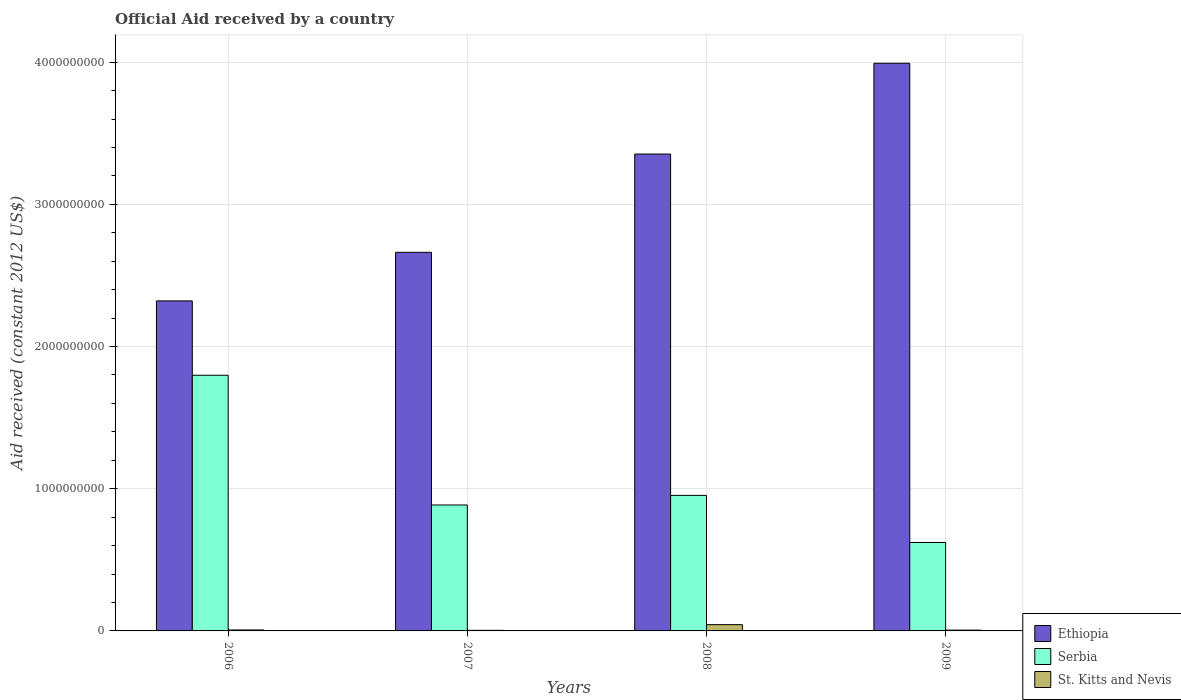How many different coloured bars are there?
Your response must be concise. 3. How many bars are there on the 1st tick from the left?
Your answer should be very brief. 3. How many bars are there on the 4th tick from the right?
Keep it short and to the point. 3. What is the label of the 4th group of bars from the left?
Give a very brief answer. 2009. In how many cases, is the number of bars for a given year not equal to the number of legend labels?
Your answer should be very brief. 0. What is the net official aid received in St. Kitts and Nevis in 2008?
Offer a very short reply. 4.41e+07. Across all years, what is the maximum net official aid received in Ethiopia?
Make the answer very short. 3.99e+09. Across all years, what is the minimum net official aid received in Serbia?
Give a very brief answer. 6.22e+08. In which year was the net official aid received in Serbia minimum?
Make the answer very short. 2009. What is the total net official aid received in St. Kitts and Nevis in the graph?
Your answer should be very brief. 6.07e+07. What is the difference between the net official aid received in Ethiopia in 2007 and that in 2008?
Give a very brief answer. -6.91e+08. What is the difference between the net official aid received in Ethiopia in 2008 and the net official aid received in St. Kitts and Nevis in 2007?
Offer a terse response. 3.35e+09. What is the average net official aid received in Ethiopia per year?
Give a very brief answer. 3.08e+09. In the year 2007, what is the difference between the net official aid received in St. Kitts and Nevis and net official aid received in Serbia?
Provide a succinct answer. -8.82e+08. In how many years, is the net official aid received in St. Kitts and Nevis greater than 800000000 US$?
Offer a very short reply. 0. What is the ratio of the net official aid received in St. Kitts and Nevis in 2007 to that in 2009?
Keep it short and to the point. 0.76. Is the net official aid received in Ethiopia in 2006 less than that in 2009?
Keep it short and to the point. Yes. What is the difference between the highest and the second highest net official aid received in Ethiopia?
Provide a succinct answer. 6.38e+08. What is the difference between the highest and the lowest net official aid received in St. Kitts and Nevis?
Offer a very short reply. 3.99e+07. What does the 2nd bar from the left in 2008 represents?
Offer a terse response. Serbia. What does the 1st bar from the right in 2007 represents?
Your answer should be very brief. St. Kitts and Nevis. Is it the case that in every year, the sum of the net official aid received in Serbia and net official aid received in Ethiopia is greater than the net official aid received in St. Kitts and Nevis?
Your answer should be very brief. Yes. How many bars are there?
Give a very brief answer. 12. Are all the bars in the graph horizontal?
Offer a terse response. No. What is the difference between two consecutive major ticks on the Y-axis?
Keep it short and to the point. 1.00e+09. Does the graph contain grids?
Make the answer very short. Yes. Where does the legend appear in the graph?
Make the answer very short. Bottom right. What is the title of the graph?
Your response must be concise. Official Aid received by a country. What is the label or title of the Y-axis?
Offer a very short reply. Aid received (constant 2012 US$). What is the Aid received (constant 2012 US$) in Ethiopia in 2006?
Ensure brevity in your answer.  2.32e+09. What is the Aid received (constant 2012 US$) of Serbia in 2006?
Provide a short and direct response. 1.80e+09. What is the Aid received (constant 2012 US$) of St. Kitts and Nevis in 2006?
Ensure brevity in your answer.  6.74e+06. What is the Aid received (constant 2012 US$) of Ethiopia in 2007?
Make the answer very short. 2.66e+09. What is the Aid received (constant 2012 US$) of Serbia in 2007?
Ensure brevity in your answer.  8.86e+08. What is the Aid received (constant 2012 US$) in St. Kitts and Nevis in 2007?
Give a very brief answer. 4.22e+06. What is the Aid received (constant 2012 US$) in Ethiopia in 2008?
Provide a succinct answer. 3.35e+09. What is the Aid received (constant 2012 US$) of Serbia in 2008?
Provide a succinct answer. 9.53e+08. What is the Aid received (constant 2012 US$) in St. Kitts and Nevis in 2008?
Your answer should be very brief. 4.41e+07. What is the Aid received (constant 2012 US$) of Ethiopia in 2009?
Keep it short and to the point. 3.99e+09. What is the Aid received (constant 2012 US$) of Serbia in 2009?
Ensure brevity in your answer.  6.22e+08. What is the Aid received (constant 2012 US$) in St. Kitts and Nevis in 2009?
Your answer should be very brief. 5.58e+06. Across all years, what is the maximum Aid received (constant 2012 US$) of Ethiopia?
Provide a short and direct response. 3.99e+09. Across all years, what is the maximum Aid received (constant 2012 US$) in Serbia?
Ensure brevity in your answer.  1.80e+09. Across all years, what is the maximum Aid received (constant 2012 US$) in St. Kitts and Nevis?
Your response must be concise. 4.41e+07. Across all years, what is the minimum Aid received (constant 2012 US$) of Ethiopia?
Offer a very short reply. 2.32e+09. Across all years, what is the minimum Aid received (constant 2012 US$) in Serbia?
Your answer should be very brief. 6.22e+08. Across all years, what is the minimum Aid received (constant 2012 US$) of St. Kitts and Nevis?
Your answer should be compact. 4.22e+06. What is the total Aid received (constant 2012 US$) in Ethiopia in the graph?
Offer a very short reply. 1.23e+1. What is the total Aid received (constant 2012 US$) of Serbia in the graph?
Offer a terse response. 4.26e+09. What is the total Aid received (constant 2012 US$) in St. Kitts and Nevis in the graph?
Offer a terse response. 6.07e+07. What is the difference between the Aid received (constant 2012 US$) of Ethiopia in 2006 and that in 2007?
Your response must be concise. -3.42e+08. What is the difference between the Aid received (constant 2012 US$) of Serbia in 2006 and that in 2007?
Your answer should be very brief. 9.12e+08. What is the difference between the Aid received (constant 2012 US$) in St. Kitts and Nevis in 2006 and that in 2007?
Your answer should be very brief. 2.52e+06. What is the difference between the Aid received (constant 2012 US$) of Ethiopia in 2006 and that in 2008?
Offer a terse response. -1.03e+09. What is the difference between the Aid received (constant 2012 US$) of Serbia in 2006 and that in 2008?
Provide a succinct answer. 8.45e+08. What is the difference between the Aid received (constant 2012 US$) of St. Kitts and Nevis in 2006 and that in 2008?
Provide a short and direct response. -3.74e+07. What is the difference between the Aid received (constant 2012 US$) of Ethiopia in 2006 and that in 2009?
Keep it short and to the point. -1.67e+09. What is the difference between the Aid received (constant 2012 US$) in Serbia in 2006 and that in 2009?
Provide a short and direct response. 1.18e+09. What is the difference between the Aid received (constant 2012 US$) in St. Kitts and Nevis in 2006 and that in 2009?
Your answer should be compact. 1.16e+06. What is the difference between the Aid received (constant 2012 US$) of Ethiopia in 2007 and that in 2008?
Your answer should be compact. -6.91e+08. What is the difference between the Aid received (constant 2012 US$) of Serbia in 2007 and that in 2008?
Ensure brevity in your answer.  -6.75e+07. What is the difference between the Aid received (constant 2012 US$) in St. Kitts and Nevis in 2007 and that in 2008?
Provide a short and direct response. -3.99e+07. What is the difference between the Aid received (constant 2012 US$) in Ethiopia in 2007 and that in 2009?
Provide a succinct answer. -1.33e+09. What is the difference between the Aid received (constant 2012 US$) of Serbia in 2007 and that in 2009?
Provide a succinct answer. 2.64e+08. What is the difference between the Aid received (constant 2012 US$) in St. Kitts and Nevis in 2007 and that in 2009?
Your answer should be very brief. -1.36e+06. What is the difference between the Aid received (constant 2012 US$) of Ethiopia in 2008 and that in 2009?
Give a very brief answer. -6.38e+08. What is the difference between the Aid received (constant 2012 US$) of Serbia in 2008 and that in 2009?
Provide a short and direct response. 3.31e+08. What is the difference between the Aid received (constant 2012 US$) of St. Kitts and Nevis in 2008 and that in 2009?
Ensure brevity in your answer.  3.86e+07. What is the difference between the Aid received (constant 2012 US$) of Ethiopia in 2006 and the Aid received (constant 2012 US$) of Serbia in 2007?
Offer a terse response. 1.44e+09. What is the difference between the Aid received (constant 2012 US$) of Ethiopia in 2006 and the Aid received (constant 2012 US$) of St. Kitts and Nevis in 2007?
Offer a terse response. 2.32e+09. What is the difference between the Aid received (constant 2012 US$) of Serbia in 2006 and the Aid received (constant 2012 US$) of St. Kitts and Nevis in 2007?
Your response must be concise. 1.79e+09. What is the difference between the Aid received (constant 2012 US$) of Ethiopia in 2006 and the Aid received (constant 2012 US$) of Serbia in 2008?
Offer a terse response. 1.37e+09. What is the difference between the Aid received (constant 2012 US$) of Ethiopia in 2006 and the Aid received (constant 2012 US$) of St. Kitts and Nevis in 2008?
Your answer should be compact. 2.28e+09. What is the difference between the Aid received (constant 2012 US$) in Serbia in 2006 and the Aid received (constant 2012 US$) in St. Kitts and Nevis in 2008?
Your answer should be compact. 1.75e+09. What is the difference between the Aid received (constant 2012 US$) in Ethiopia in 2006 and the Aid received (constant 2012 US$) in Serbia in 2009?
Ensure brevity in your answer.  1.70e+09. What is the difference between the Aid received (constant 2012 US$) of Ethiopia in 2006 and the Aid received (constant 2012 US$) of St. Kitts and Nevis in 2009?
Provide a short and direct response. 2.32e+09. What is the difference between the Aid received (constant 2012 US$) of Serbia in 2006 and the Aid received (constant 2012 US$) of St. Kitts and Nevis in 2009?
Provide a succinct answer. 1.79e+09. What is the difference between the Aid received (constant 2012 US$) of Ethiopia in 2007 and the Aid received (constant 2012 US$) of Serbia in 2008?
Your answer should be very brief. 1.71e+09. What is the difference between the Aid received (constant 2012 US$) in Ethiopia in 2007 and the Aid received (constant 2012 US$) in St. Kitts and Nevis in 2008?
Ensure brevity in your answer.  2.62e+09. What is the difference between the Aid received (constant 2012 US$) of Serbia in 2007 and the Aid received (constant 2012 US$) of St. Kitts and Nevis in 2008?
Give a very brief answer. 8.42e+08. What is the difference between the Aid received (constant 2012 US$) in Ethiopia in 2007 and the Aid received (constant 2012 US$) in Serbia in 2009?
Offer a terse response. 2.04e+09. What is the difference between the Aid received (constant 2012 US$) in Ethiopia in 2007 and the Aid received (constant 2012 US$) in St. Kitts and Nevis in 2009?
Your answer should be very brief. 2.66e+09. What is the difference between the Aid received (constant 2012 US$) in Serbia in 2007 and the Aid received (constant 2012 US$) in St. Kitts and Nevis in 2009?
Offer a terse response. 8.80e+08. What is the difference between the Aid received (constant 2012 US$) of Ethiopia in 2008 and the Aid received (constant 2012 US$) of Serbia in 2009?
Make the answer very short. 2.73e+09. What is the difference between the Aid received (constant 2012 US$) in Ethiopia in 2008 and the Aid received (constant 2012 US$) in St. Kitts and Nevis in 2009?
Provide a short and direct response. 3.35e+09. What is the difference between the Aid received (constant 2012 US$) in Serbia in 2008 and the Aid received (constant 2012 US$) in St. Kitts and Nevis in 2009?
Offer a very short reply. 9.48e+08. What is the average Aid received (constant 2012 US$) of Ethiopia per year?
Make the answer very short. 3.08e+09. What is the average Aid received (constant 2012 US$) in Serbia per year?
Ensure brevity in your answer.  1.06e+09. What is the average Aid received (constant 2012 US$) in St. Kitts and Nevis per year?
Provide a short and direct response. 1.52e+07. In the year 2006, what is the difference between the Aid received (constant 2012 US$) in Ethiopia and Aid received (constant 2012 US$) in Serbia?
Your answer should be very brief. 5.23e+08. In the year 2006, what is the difference between the Aid received (constant 2012 US$) of Ethiopia and Aid received (constant 2012 US$) of St. Kitts and Nevis?
Give a very brief answer. 2.31e+09. In the year 2006, what is the difference between the Aid received (constant 2012 US$) in Serbia and Aid received (constant 2012 US$) in St. Kitts and Nevis?
Ensure brevity in your answer.  1.79e+09. In the year 2007, what is the difference between the Aid received (constant 2012 US$) in Ethiopia and Aid received (constant 2012 US$) in Serbia?
Offer a very short reply. 1.78e+09. In the year 2007, what is the difference between the Aid received (constant 2012 US$) of Ethiopia and Aid received (constant 2012 US$) of St. Kitts and Nevis?
Provide a succinct answer. 2.66e+09. In the year 2007, what is the difference between the Aid received (constant 2012 US$) in Serbia and Aid received (constant 2012 US$) in St. Kitts and Nevis?
Keep it short and to the point. 8.82e+08. In the year 2008, what is the difference between the Aid received (constant 2012 US$) in Ethiopia and Aid received (constant 2012 US$) in Serbia?
Your answer should be very brief. 2.40e+09. In the year 2008, what is the difference between the Aid received (constant 2012 US$) of Ethiopia and Aid received (constant 2012 US$) of St. Kitts and Nevis?
Your answer should be compact. 3.31e+09. In the year 2008, what is the difference between the Aid received (constant 2012 US$) in Serbia and Aid received (constant 2012 US$) in St. Kitts and Nevis?
Your response must be concise. 9.09e+08. In the year 2009, what is the difference between the Aid received (constant 2012 US$) of Ethiopia and Aid received (constant 2012 US$) of Serbia?
Offer a terse response. 3.37e+09. In the year 2009, what is the difference between the Aid received (constant 2012 US$) in Ethiopia and Aid received (constant 2012 US$) in St. Kitts and Nevis?
Make the answer very short. 3.99e+09. In the year 2009, what is the difference between the Aid received (constant 2012 US$) in Serbia and Aid received (constant 2012 US$) in St. Kitts and Nevis?
Keep it short and to the point. 6.16e+08. What is the ratio of the Aid received (constant 2012 US$) in Ethiopia in 2006 to that in 2007?
Offer a very short reply. 0.87. What is the ratio of the Aid received (constant 2012 US$) in Serbia in 2006 to that in 2007?
Ensure brevity in your answer.  2.03. What is the ratio of the Aid received (constant 2012 US$) of St. Kitts and Nevis in 2006 to that in 2007?
Offer a very short reply. 1.6. What is the ratio of the Aid received (constant 2012 US$) in Ethiopia in 2006 to that in 2008?
Provide a succinct answer. 0.69. What is the ratio of the Aid received (constant 2012 US$) in Serbia in 2006 to that in 2008?
Keep it short and to the point. 1.89. What is the ratio of the Aid received (constant 2012 US$) in St. Kitts and Nevis in 2006 to that in 2008?
Offer a very short reply. 0.15. What is the ratio of the Aid received (constant 2012 US$) in Ethiopia in 2006 to that in 2009?
Your answer should be compact. 0.58. What is the ratio of the Aid received (constant 2012 US$) in Serbia in 2006 to that in 2009?
Provide a short and direct response. 2.89. What is the ratio of the Aid received (constant 2012 US$) of St. Kitts and Nevis in 2006 to that in 2009?
Your answer should be compact. 1.21. What is the ratio of the Aid received (constant 2012 US$) of Ethiopia in 2007 to that in 2008?
Keep it short and to the point. 0.79. What is the ratio of the Aid received (constant 2012 US$) of Serbia in 2007 to that in 2008?
Your response must be concise. 0.93. What is the ratio of the Aid received (constant 2012 US$) in St. Kitts and Nevis in 2007 to that in 2008?
Provide a short and direct response. 0.1. What is the ratio of the Aid received (constant 2012 US$) in Ethiopia in 2007 to that in 2009?
Your answer should be very brief. 0.67. What is the ratio of the Aid received (constant 2012 US$) of Serbia in 2007 to that in 2009?
Your answer should be compact. 1.42. What is the ratio of the Aid received (constant 2012 US$) in St. Kitts and Nevis in 2007 to that in 2009?
Provide a short and direct response. 0.76. What is the ratio of the Aid received (constant 2012 US$) in Ethiopia in 2008 to that in 2009?
Offer a very short reply. 0.84. What is the ratio of the Aid received (constant 2012 US$) of Serbia in 2008 to that in 2009?
Offer a terse response. 1.53. What is the ratio of the Aid received (constant 2012 US$) of St. Kitts and Nevis in 2008 to that in 2009?
Offer a very short reply. 7.91. What is the difference between the highest and the second highest Aid received (constant 2012 US$) of Ethiopia?
Offer a very short reply. 6.38e+08. What is the difference between the highest and the second highest Aid received (constant 2012 US$) of Serbia?
Offer a very short reply. 8.45e+08. What is the difference between the highest and the second highest Aid received (constant 2012 US$) of St. Kitts and Nevis?
Keep it short and to the point. 3.74e+07. What is the difference between the highest and the lowest Aid received (constant 2012 US$) of Ethiopia?
Your answer should be very brief. 1.67e+09. What is the difference between the highest and the lowest Aid received (constant 2012 US$) of Serbia?
Your response must be concise. 1.18e+09. What is the difference between the highest and the lowest Aid received (constant 2012 US$) of St. Kitts and Nevis?
Provide a succinct answer. 3.99e+07. 